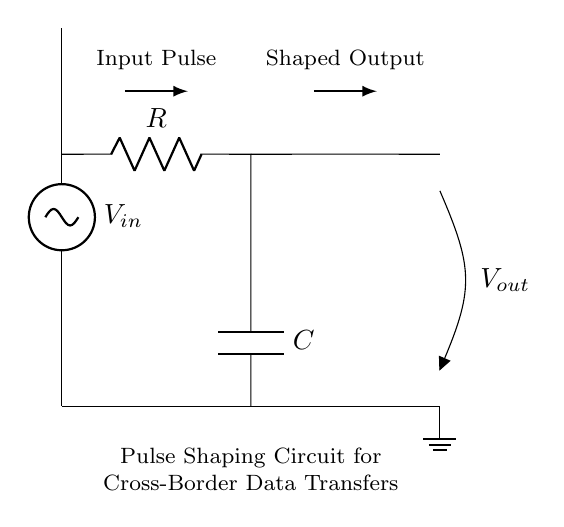What is the type of the input signal? The input signal is labeled as a voltage source with V_in, indicating it may represent a digital pulse.
Answer: voltage source How many main components are in the circuit? There are two main components: a resistor and a capacitor, which are connected in series.
Answer: two What is the function of the resistor in this circuit? The resistor limits the current flowing through the circuit and affects the time constant for the charging and discharging of the capacitor.
Answer: current limiting What is the purpose of the capacitor in this circuit? The capacitor stores and releases energy, shaping the output pulse by smoothing out rapid changes in voltage.
Answer: pulse shaping What is the expected output form compared to the input? The output is expected to be a shaped signal, specifically a smoothed or rounded version of the input pulse.
Answer: shaped signal What is the impact of resistor and capacitor values on pulse shaping? The values of the resistor and capacitor determine the time constant, influencing the rise and fall times of the output pulse, which is critical for signal integrity.
Answer: time constant How does this circuit contribute to cross-border data transfer? This pulse shaping circuit enhances signal integrity by reducing noise and distortion, which is vital for maintaining data integrity over long distances.
Answer: signal integrity 